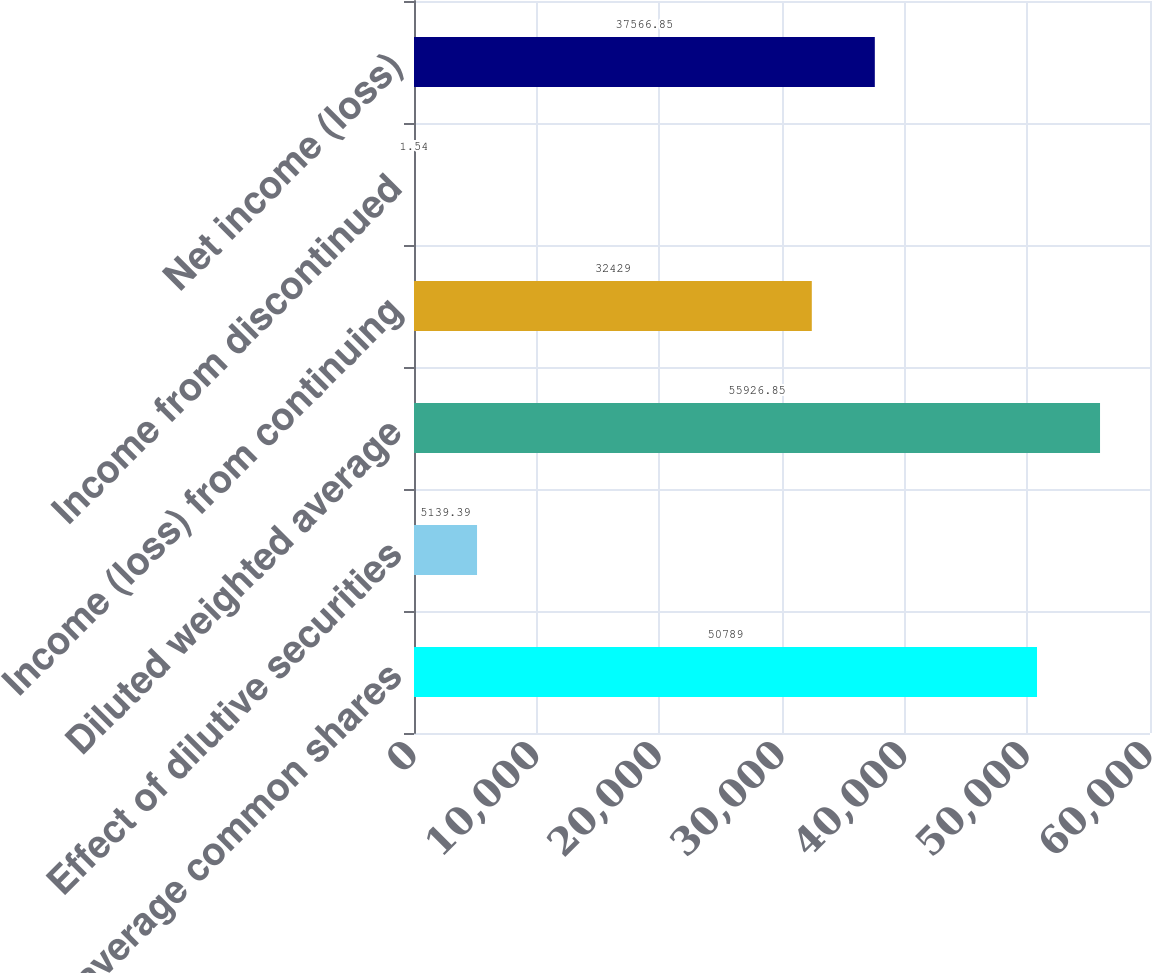<chart> <loc_0><loc_0><loc_500><loc_500><bar_chart><fcel>Weighted average common shares<fcel>Effect of dilutive securities<fcel>Diluted weighted average<fcel>Income (loss) from continuing<fcel>Income from discontinued<fcel>Net income (loss)<nl><fcel>50789<fcel>5139.39<fcel>55926.8<fcel>32429<fcel>1.54<fcel>37566.8<nl></chart> 